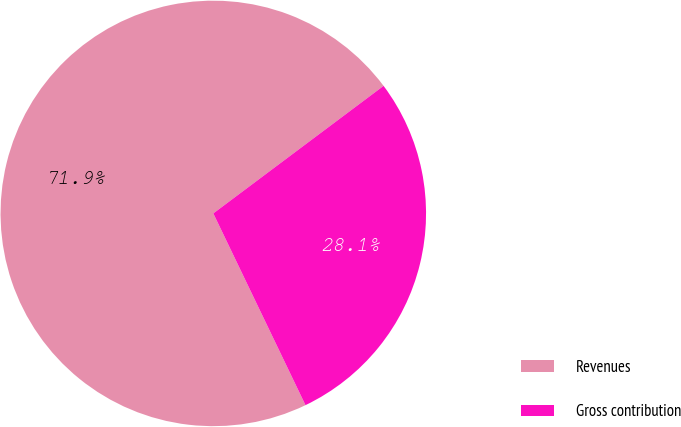Convert chart. <chart><loc_0><loc_0><loc_500><loc_500><pie_chart><fcel>Revenues<fcel>Gross contribution<nl><fcel>71.9%<fcel>28.1%<nl></chart> 